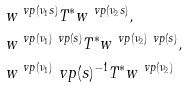Convert formula to latex. <formula><loc_0><loc_0><loc_500><loc_500>& w ^ { \ v p ( \nu _ { 1 } s ) } T ^ { * } w ^ { \ v p ( \nu _ { 2 } s ) } , \\ & w ^ { \ v p ( \nu _ { 1 } ) \ v p ( s ) } T ^ { * } w ^ { \ v p ( \nu _ { 2 } ) \ v p ( s ) } , \\ & w ^ { \ v p ( \nu _ { 1 } ) } \ v p ( s ) ^ { - 1 } T ^ { * } w ^ { \ v p ( \nu _ { 2 } ) }</formula> 